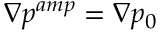<formula> <loc_0><loc_0><loc_500><loc_500>\nabla p ^ { a m p } = \nabla p _ { 0 }</formula> 